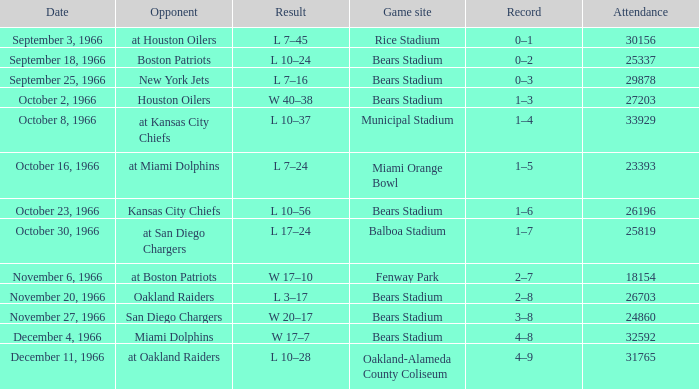On October 16, 1966, what was the game site? Miami Orange Bowl. 